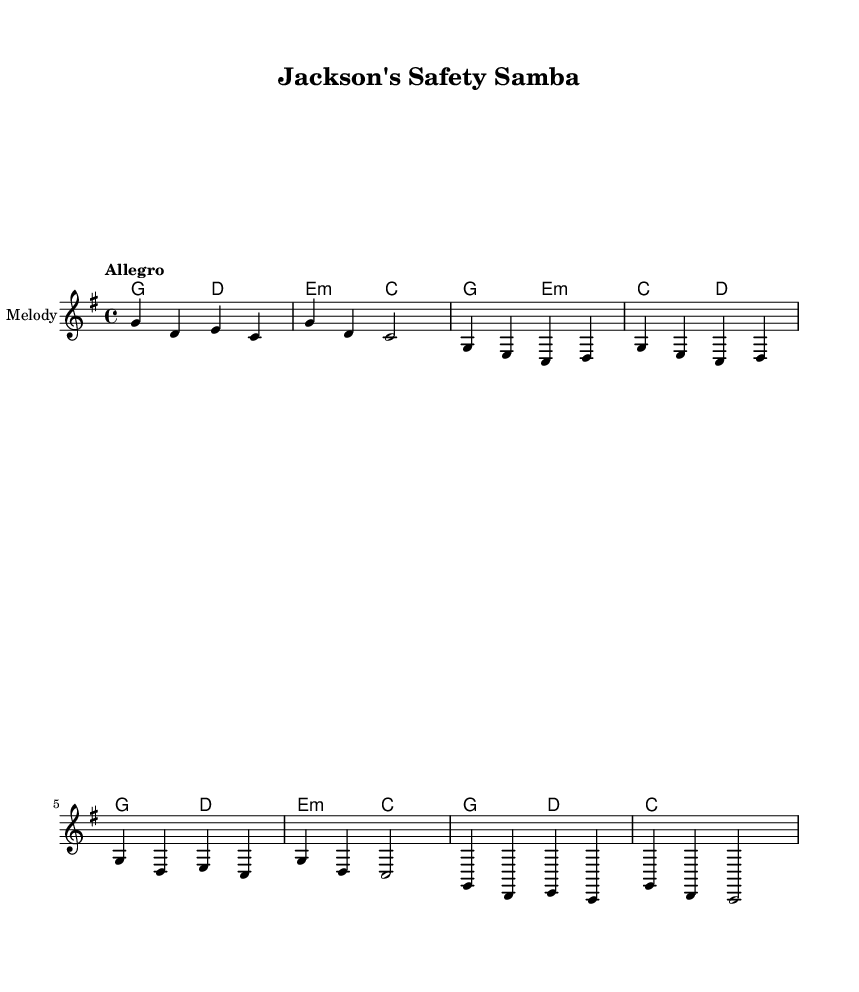What is the key signature of this music? The key signature is indicated at the beginning of the staff. It shows one sharp, which confirms it is in G major.
Answer: G major What is the time signature of this music? The time signature is typically found at the beginning of the score. It shows a numeral represented as a fraction, in this case, 4 over 4, indicating there are four beats per measure.
Answer: 4/4 What is the tempo marking in this piece? The tempo marking is written above the staff, showing the speed of the music. In this case, it indicates "Allegro," which means fast or lively.
Answer: Allegro How many measures are in the chorus section? The chorus section can be determined by counting the length of the corresponding notes and phrases marked within the melody section. It consists of four measures.
Answer: Four What chords accompany the intro of the music? The intro contains specific chords that are laid out in the chord mode section, which are G and D followed by E minor and C.
Answer: G, D, E minor, C What theme do the lyrics in the verse express? To find the theme, analyzing the lyrics in the verse section will show that they pertain to walking in Jackson town, which reflects urban experiences and concerns.
Answer: Urban experiences How does the chorus relate to urban safety concerns? Analyzing the lyrics shows that the chorus emphasizes that safety is a priority in Jackson, connecting with the theme of safety issues in urban contexts.
Answer: Safety is a priority 